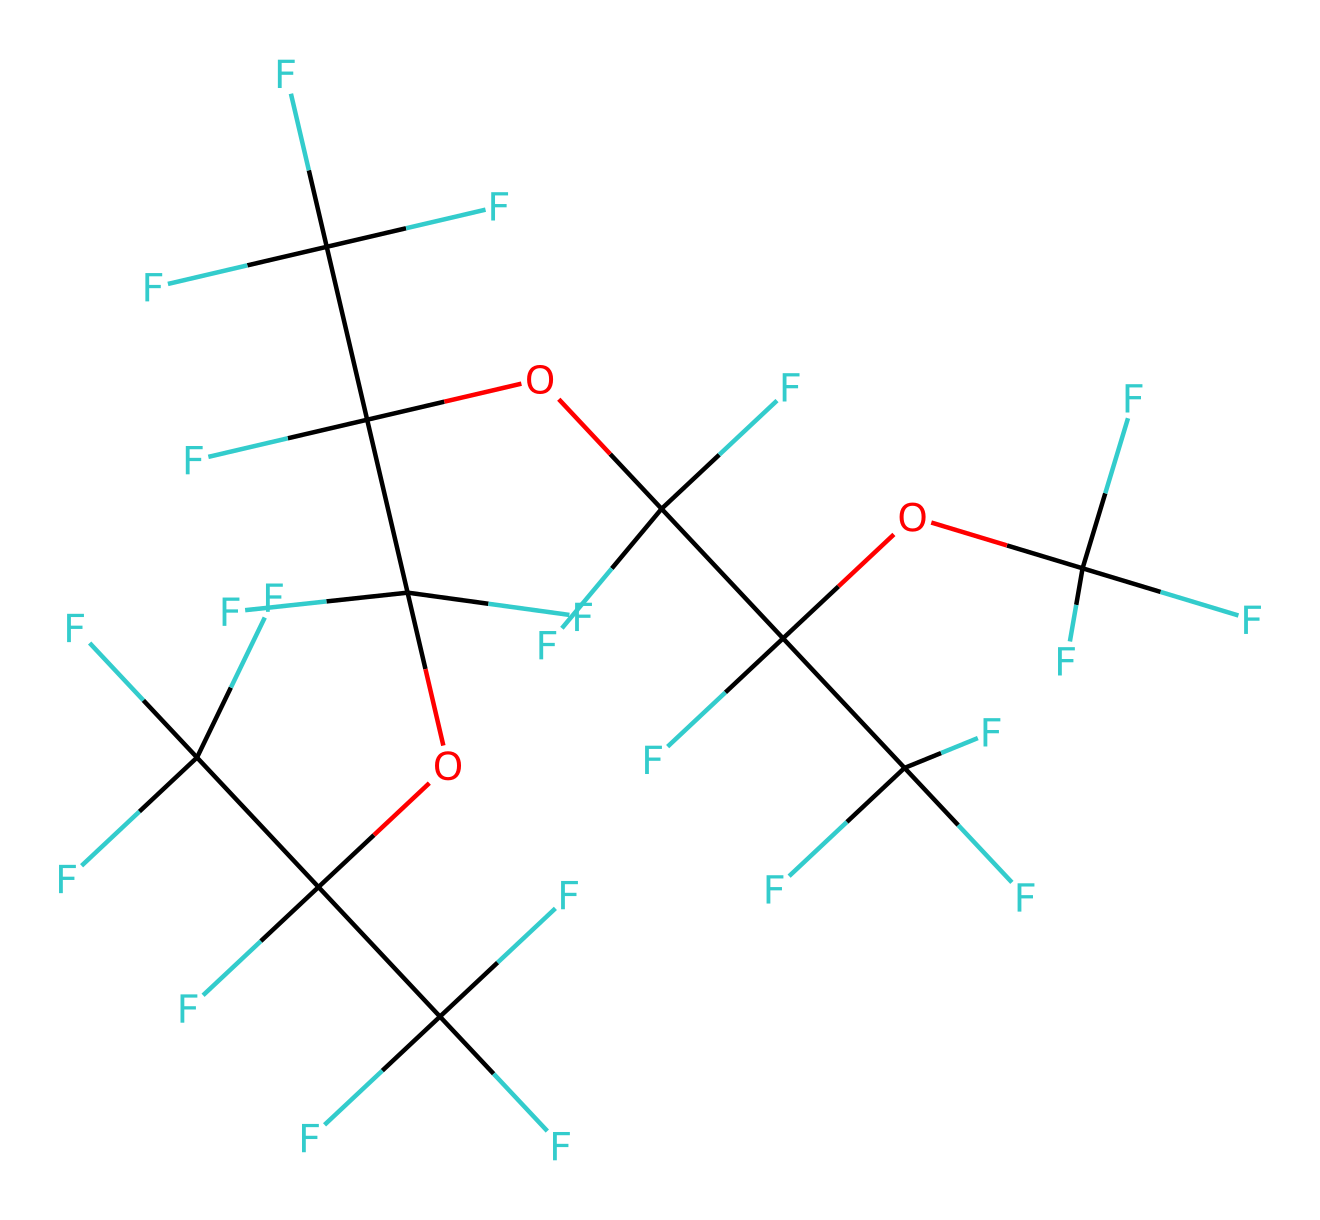How many carbon atoms are present in this PFPE lubricant? By analyzing the SMILES representation, we count the number of carbon atoms. Each 'C' in the structure indicates a carbon atom. Given the structure, we identify a total of 11 carbon atoms.
Answer: 11 What is the chemical family of this lubricant? The presence of multiple fluorine atoms and oxygen atoms in the structure indicates that this compound belongs to the perfluoropolyether family, which is known for its use in lubricants.
Answer: perfluoropolyether How many oxygen atoms are in this lubricant? In the SMILES representation, we can see 'O' present in the structure. Counting up the occurrences, we find that there are 3 oxygen atoms in this PFPE lubricant.
Answer: 3 What is the primary characteristic of PFPE lubricants that allows them to perform in extreme conditions? The significant presence of fluorine atoms in this lubricant gives it high thermal stability and excellent chemical resistance, making it suitable for extreme conditions.
Answer: high thermal stability How does the molecular structure contribute to the lubricant’s low surface tension? The fluorinated structure of PFPE reduces the intermolecular forces significantly, resulting in lower surface tension. This is due to the unique arrangement of fluorine atoms surrounding the carbon backbone.
Answer: low surface tension What is the role of fluorine in this lubricant’s properties? Fluorine atoms enhance the lubricant's chemical stability, reduce reactivity, and improve lubricating properties. This is due to their electronegativity and the strength of C-F bonds resulting in longevity in extreme environments.
Answer: enhance stability 